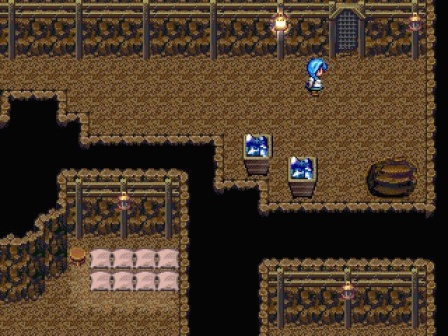What do you see happening in this image? The image presents a pixel art scene from a video game, set in a cave-like dungeon. The dungeon is constructed of brown tiles, giving it an earthy feel. In the center of the image, a character with blue hair is captured mid-stride, heading towards the right side of the scene. 

On the left side of the image, two treasure chests are visible, hinting at potential rewards or secrets within the game. A barrel is situated on the right side of the image, adding to the dungeon's decor. In the bottom left corner, a bed is tucked away, possibly indicating a resting or save point within the game. 

The dungeon is illuminated by several torches affixed to the walls, casting a warm glow over the scene. Interestingly, the top right corner of the image is shrouded in darkness, suggesting an unexplored area of the dungeon. This element adds a sense of mystery and anticipation for what lies ahead in the game. 

Overall, the image captures a moment of exploration and adventure in a classic dungeon-crawling video game. The pixel art style, combined with the detailed objects and character, creates a nostalgic and engaging gaming scene. 